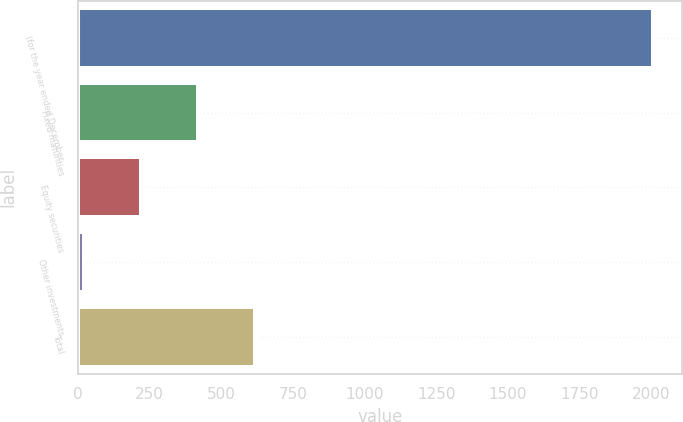<chart> <loc_0><loc_0><loc_500><loc_500><bar_chart><fcel>(for the year ended December<fcel>Fixed maturities<fcel>Equity securities<fcel>Other investments<fcel>Total<nl><fcel>2008<fcel>419.2<fcel>220.6<fcel>22<fcel>617.8<nl></chart> 